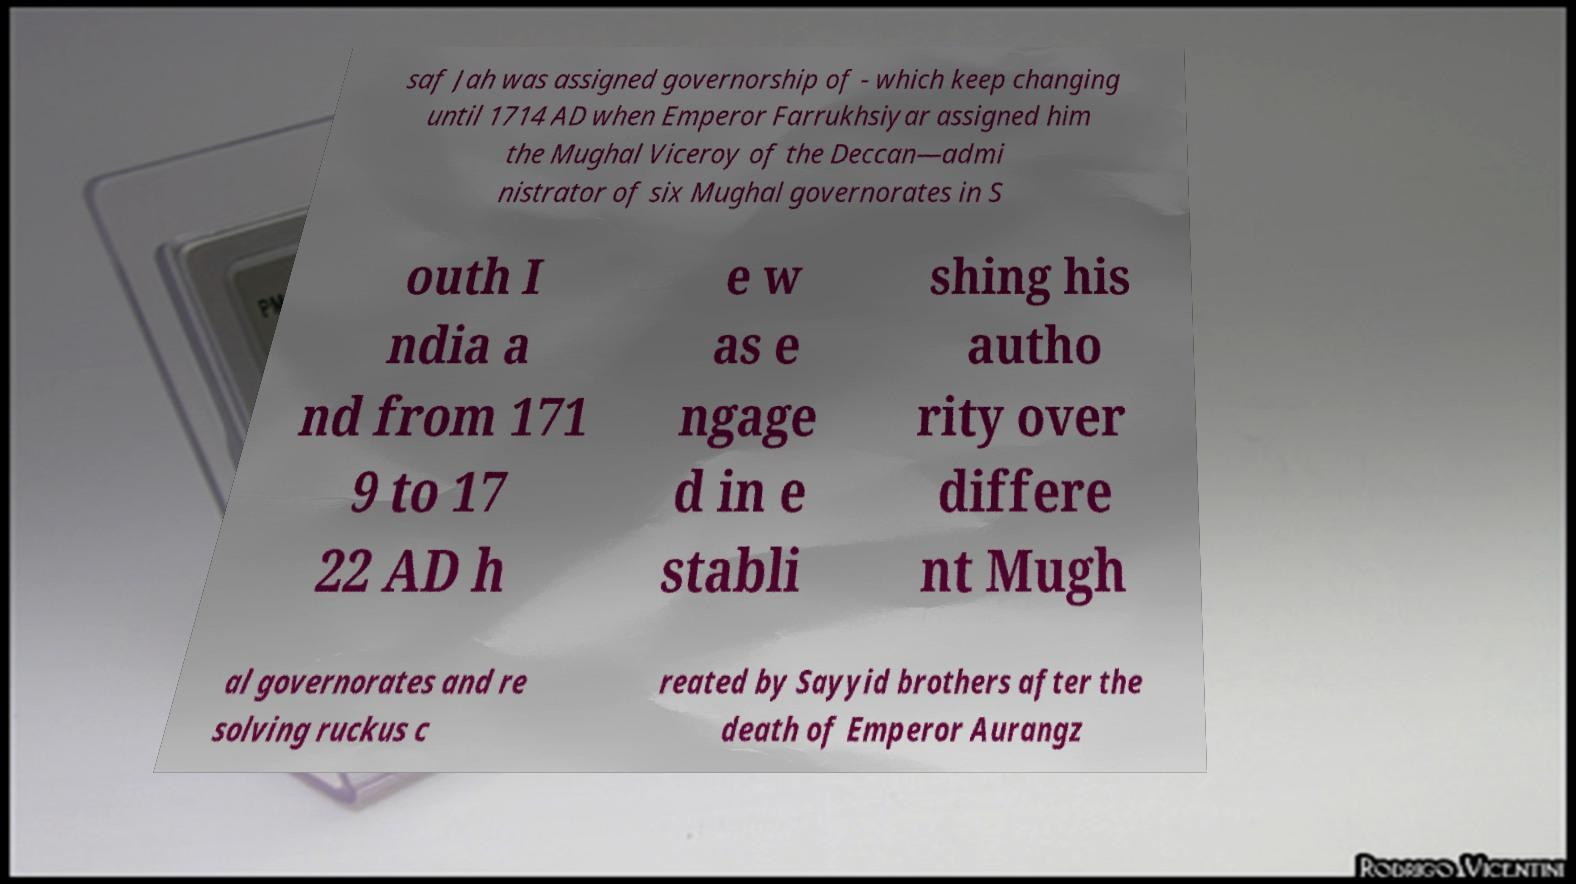Can you accurately transcribe the text from the provided image for me? saf Jah was assigned governorship of - which keep changing until 1714 AD when Emperor Farrukhsiyar assigned him the Mughal Viceroy of the Deccan—admi nistrator of six Mughal governorates in S outh I ndia a nd from 171 9 to 17 22 AD h e w as e ngage d in e stabli shing his autho rity over differe nt Mugh al governorates and re solving ruckus c reated by Sayyid brothers after the death of Emperor Aurangz 